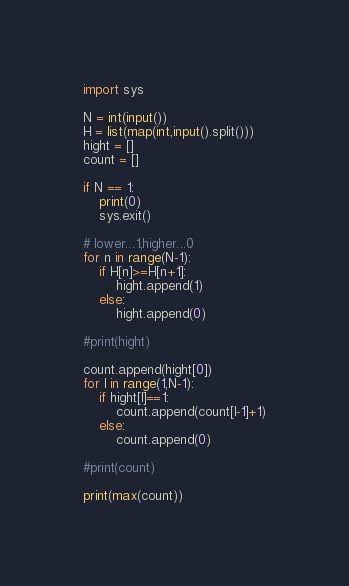<code> <loc_0><loc_0><loc_500><loc_500><_Python_>import sys

N = int(input())
H = list(map(int,input().split()))
hight = []
count = []

if N == 1:
    print(0)
    sys.exit()

# lower...1,higher...0
for n in range(N-1):
    if H[n]>=H[n+1]:
        hight.append(1)
    else:
        hight.append(0)

#print(hight)

count.append(hight[0])
for l in range(1,N-1):
    if hight[l]==1:
        count.append(count[l-1]+1)
    else:
        count.append(0)

#print(count)

print(max(count))
</code> 